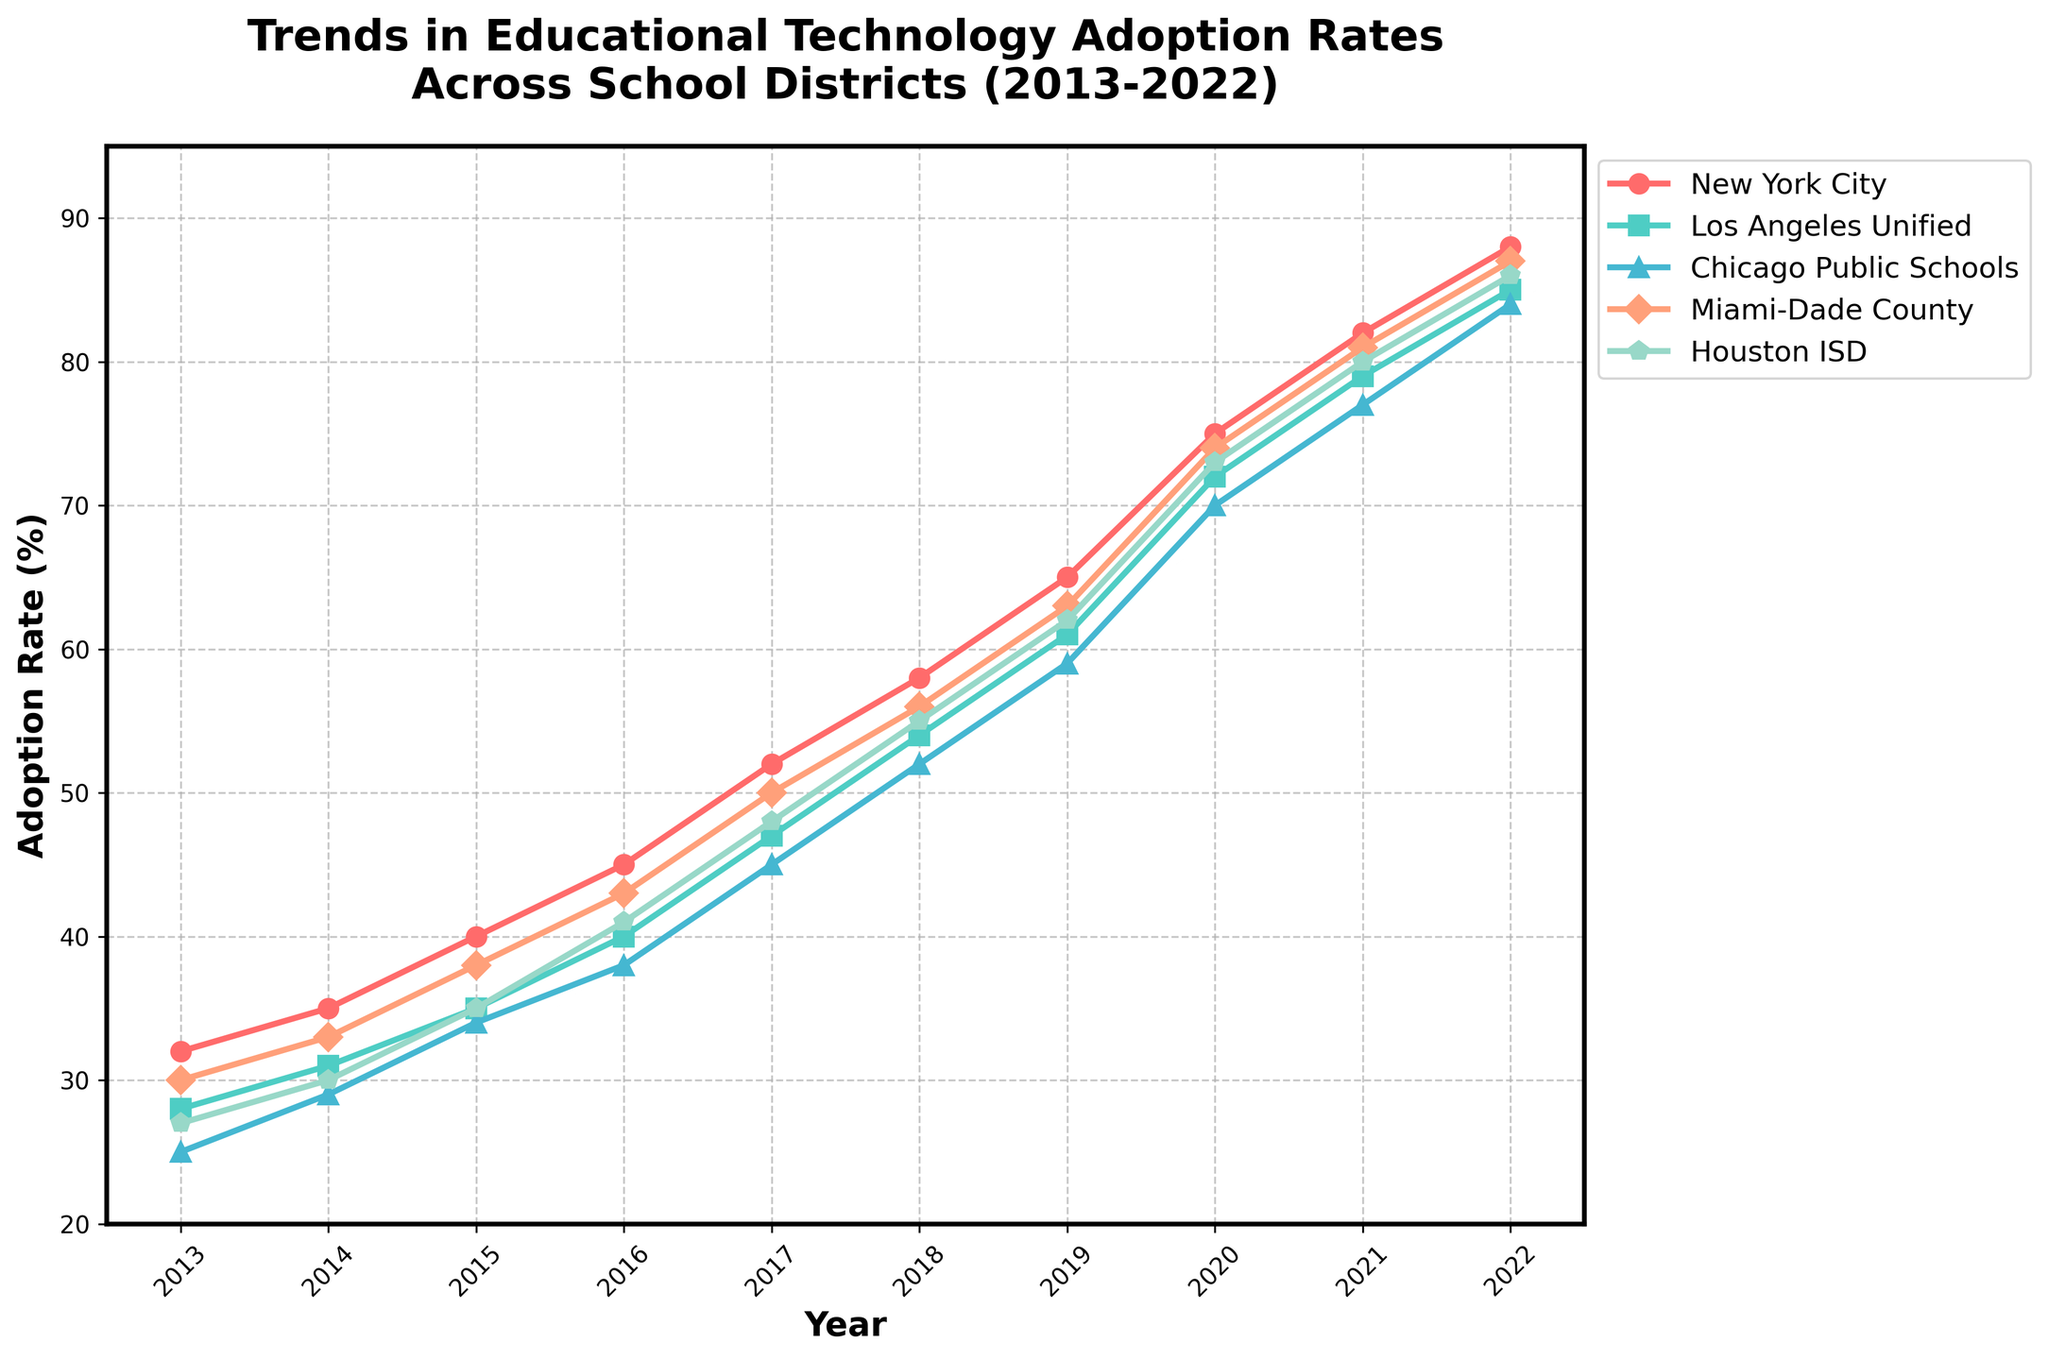Which school district had the highest adoption rate in 2022? Looking at the rightmost points on the chart, the New York City line reaches the highest point compared to other districts.
Answer: New York City When did Los Angeles Unified first surpass a 50% adoption rate? Find where the Los Angeles Unified line first goes above the 50% mark. This occurs in the year 2018.
Answer: 2018 How much did the adoption rate increase for Chicago Public Schools from 2013 to 2022? Subtract the 2013 adoption rate for Chicago Public Schools (25%) from the 2022 adoption rate (84%). The increase is 84 - 25 = 59%.
Answer: 59% Which two districts had the most similar adoption rates in 2020? Compare the heights of the lines at the year 2020 and find the closest values. Both Miami-Dade County (74%) and Houston ISD (73%) are very close.
Answer: Miami-Dade County, Houston ISD On average, what was the adoption rate of Miami-Dade County over the decade? Add the yearly adoption rates from 2013 to 2022 and divide by the number of years:
(30+33+38+43+50+56+63+74+81+87)/10 = 555/10 = 55.5%
Answer: 55.5% In which year did New York City see the largest single-year increase in adoption rate? Compare the differences in the heights of New York City's line between consecutive years. The largest increase is from 2019 (65%) to 2020 (75%), which is a 10% increase.
Answer: 2020 Which district showed consistent year-over-year growth without any drops? Reviewing the trends of all lines, all districts show consistent growth without any drops.
Answer: All districts By how many percentage points did Houston ISD's adoption rate change from 2017 to 2019? Subtract the 2017 adoption rate (48%) from the 2019 rate (62%): 62 - 48 = 14%.
Answer: 14% What is the visual trend for educational technology adoption rates from 2013 to 2022? The visual trend for all districts shows a steady and consistent increase over this period.
Answer: Steady increase Between 2015 and 2021, which district had the highest average adoption rate? Calculate the average adoption rate for each district between these years and compare them:
- New York City: (40+45+52+58+65+75+82)/7 = 59.57
- Los Angeles Unified: (35+40+47+54+61+72+79)/7 = 55.43
- Chicago Public Schools: (34+38+45+52+59+70+77)/7 = 53.57
- Miami-Dade County: (38+43+50+56+63+74+81)/7 = 57.86
- Houston ISD: (35+41+48+55+62+73+80)/7 = 56.29
New York City has the highest average.
Answer: New York City 